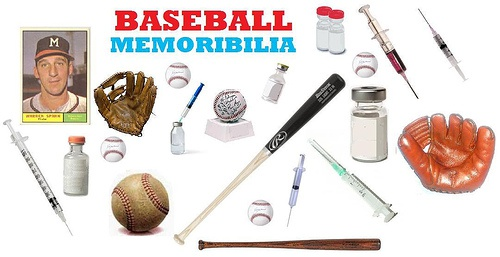Describe the objects in this image and their specific colors. I can see baseball glove in white, salmon, red, and brown tones, people in white, tan, and gray tones, baseball bat in white, ivory, black, tan, and gray tones, sports ball in white, maroon, tan, and gray tones, and baseball glove in white, maroon, olive, and gray tones in this image. 